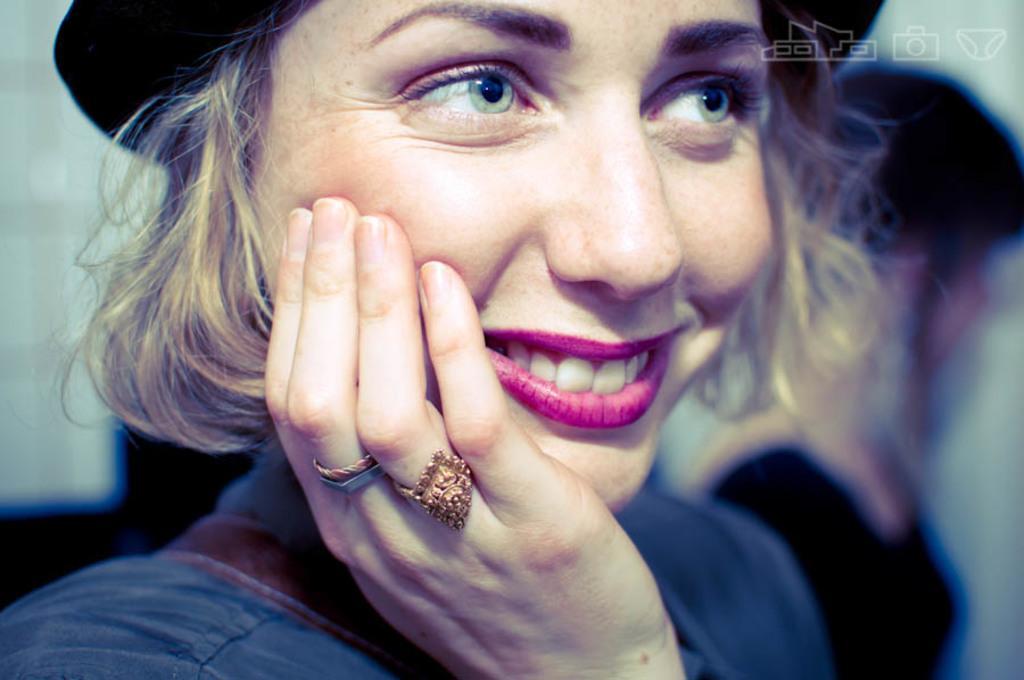Could you give a brief overview of what you see in this image? In this image we can see two persons. One woman is wearing a hat and rings on her fingers. In the top right corner of the image we can see some logos. 